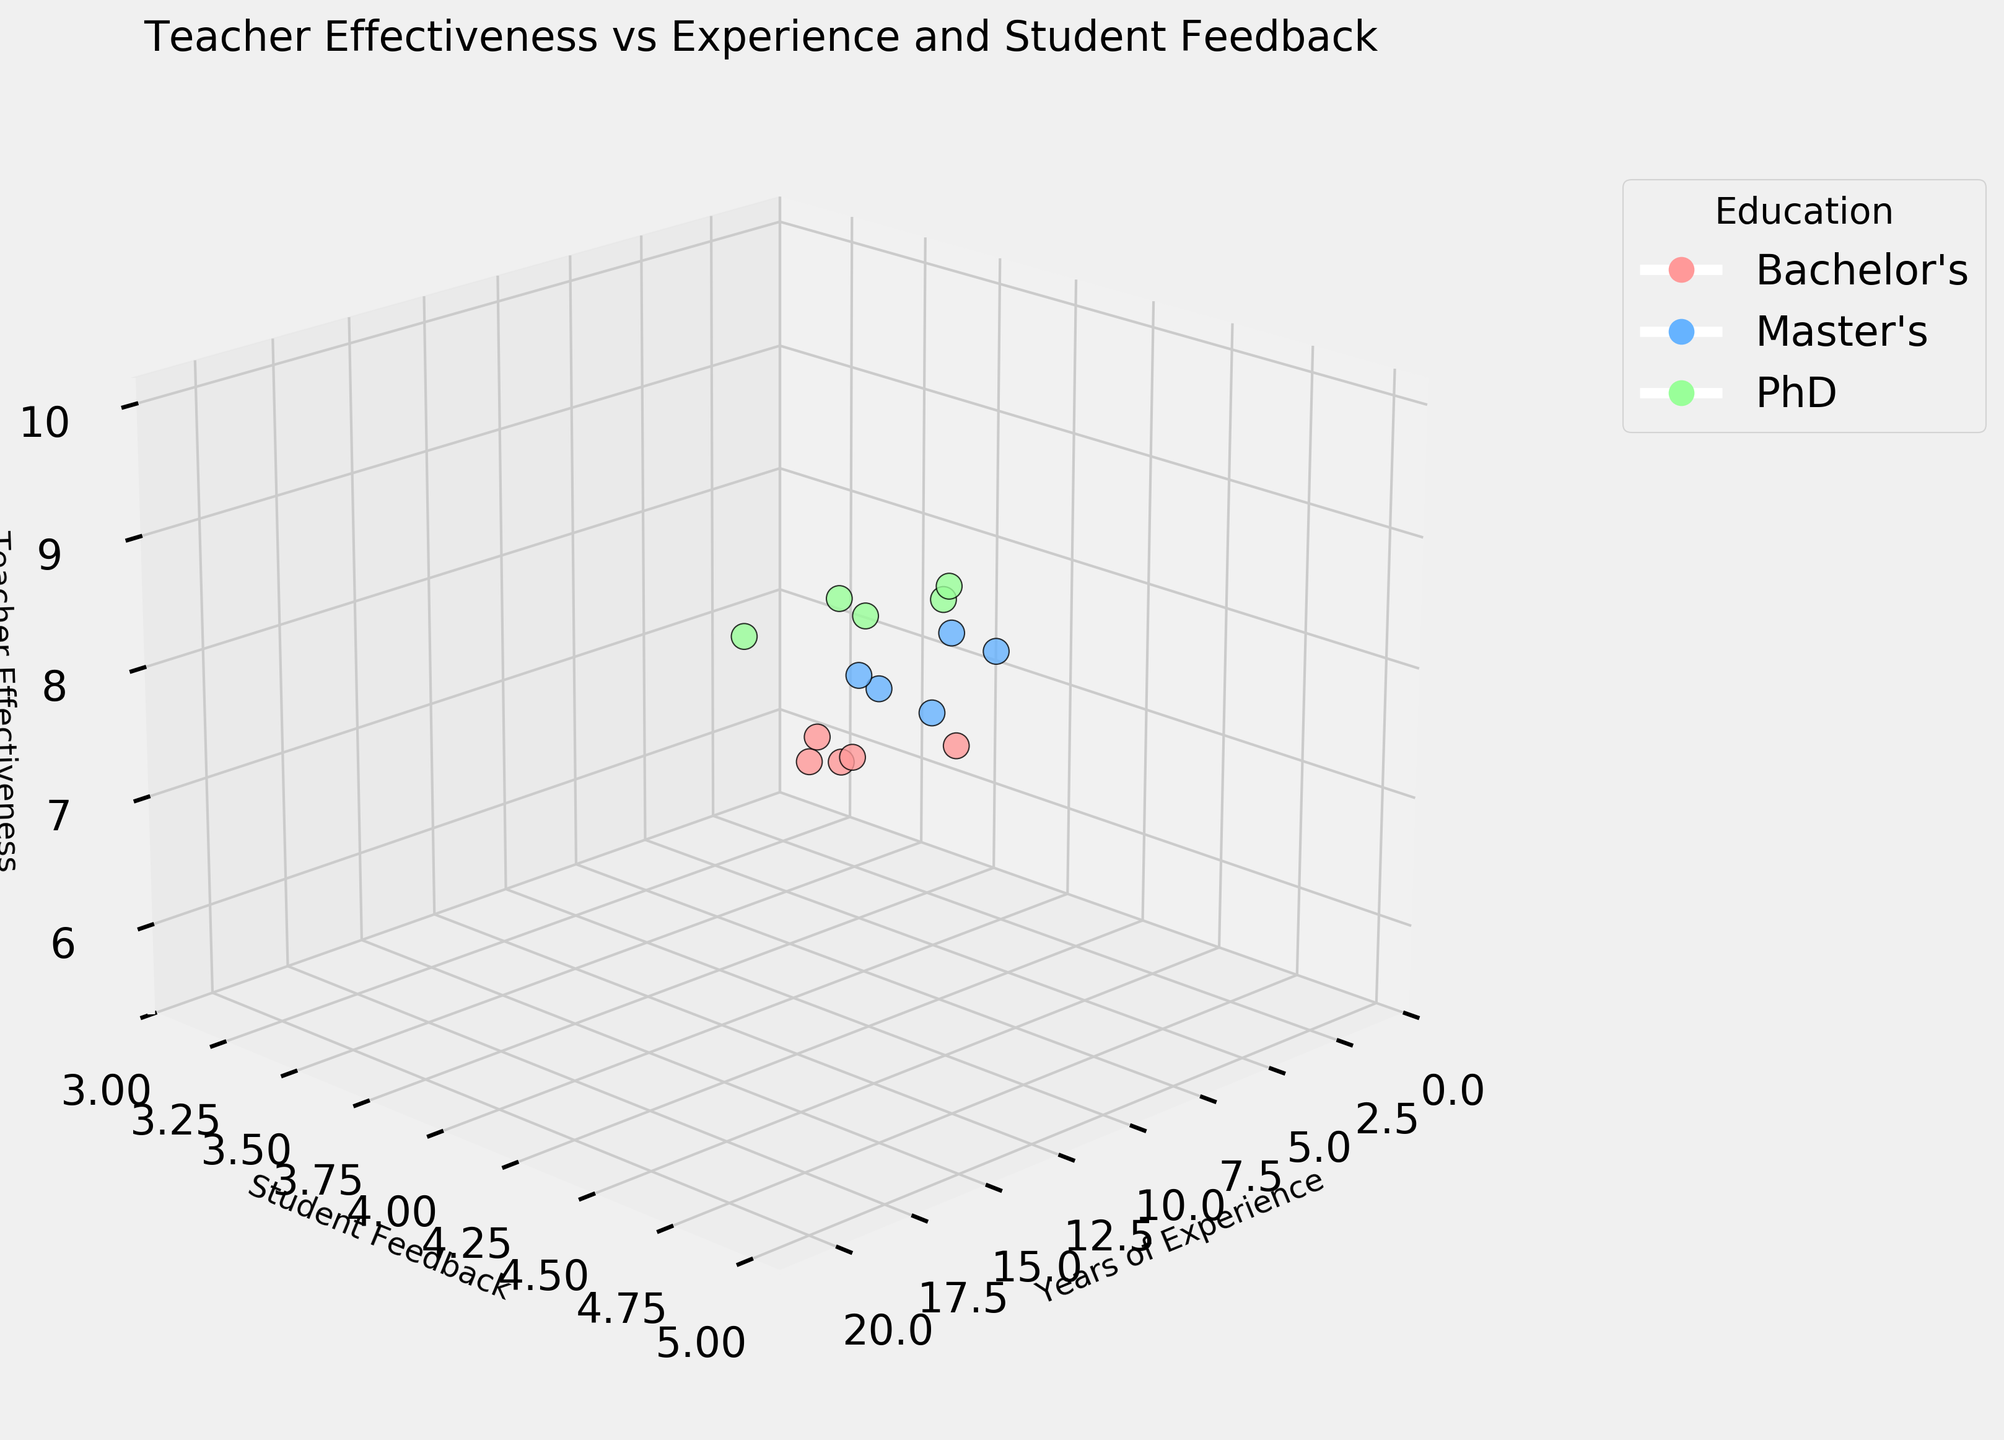What's the title of the plot? The title is displayed at the top of the figure. It reads "Teacher Effectiveness vs Experience and Student Feedback".
Answer: Teacher Effectiveness vs Experience and Student Feedback How many data points are represented in the plot? Each dot in the scatter plot represents one data point. Counting the dots gives the total number of data points.
Answer: 15 What axis is used for student feedback? The y-axis is labeled "Student Feedback," which represents the student feedback values.
Answer: y-axis Which educational background has a green color representation? By checking the legend, the color corresponding to a green shade represents the educational background. The color green is associated with PhD.
Answer: PhD What's the student feedback value for the teacher with 9 years of experience? Locate the point on the x-axis with 9 years of experience and check its corresponding y-axis value, which indicates student feedback. The y-value at this point is 4.1.
Answer: 4.1 Which teacher has the highest effectiveness rating? The teacher with the highest effectiveness rating will have the dot at the highest point on the z-axis. This teacher has an effectiveness rating of 9.7.
Answer: The teacher with 18 years experience, PhD background, and 4.9 student feedback What is the average teacher effectiveness rating for those with a Master's degree? Identify all data points with a Master's degree, sum their effectiveness ratings, and then divide by the number of Master's data points. The ratings are 7.8, 7.5, 7.0, 8.3, 8.7. The sum is 39.3, and the average is 39.3 / 5 = 7.86.
Answer: 7.86 Compare the effectiveness of teachers with a Bachelor's degree and those with a PhD. Who generally has higher ratings? First, list the effectiveness ratings for both degrees. Bachelor’s degrees: 6.5, 6.2, 5.8, 6.8, 7.2. PhD degrees: 8.9, 9.2, 8.5, 9.5, 9.7. Calculate the average for both groups: Bachelor's average = 6.5, PhD average = 9.16. PhD degrees generally have higher ratings.
Answer: Teachers with a PhD Does teacher effectiveness appear to correlate more strongly with student feedback or years of experience? Examine the distribution of the points along the z-axis relative to the y-axis (student feedback) and x-axis (years of experience). The effectiveness seems to spread more significantly along the y-axis than the x-axis, indicating a stronger correlation with student feedback.
Answer: Student feedback What can you deduce about the teacher with the lowest student feedback? Find the lowest student feedback value, which is 3.2. The corresponding teacher has 1 year of experience, a Bachelor's degree, and an effectiveness rating of 5.8.
Answer: The teacher has 1 year of experience, a Bachelor's degree, and an effectiveness rating of 5.8 